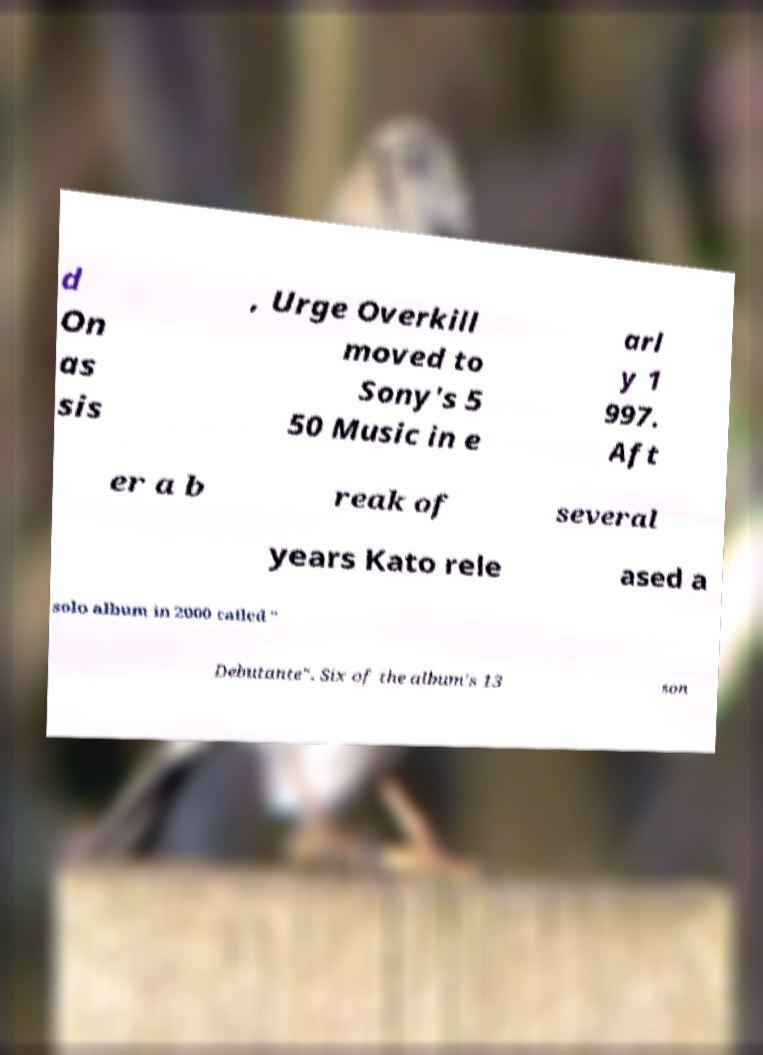Could you assist in decoding the text presented in this image and type it out clearly? d On as sis , Urge Overkill moved to Sony's 5 50 Music in e arl y 1 997. Aft er a b reak of several years Kato rele ased a solo album in 2000 called " Debutante". Six of the album's 13 son 